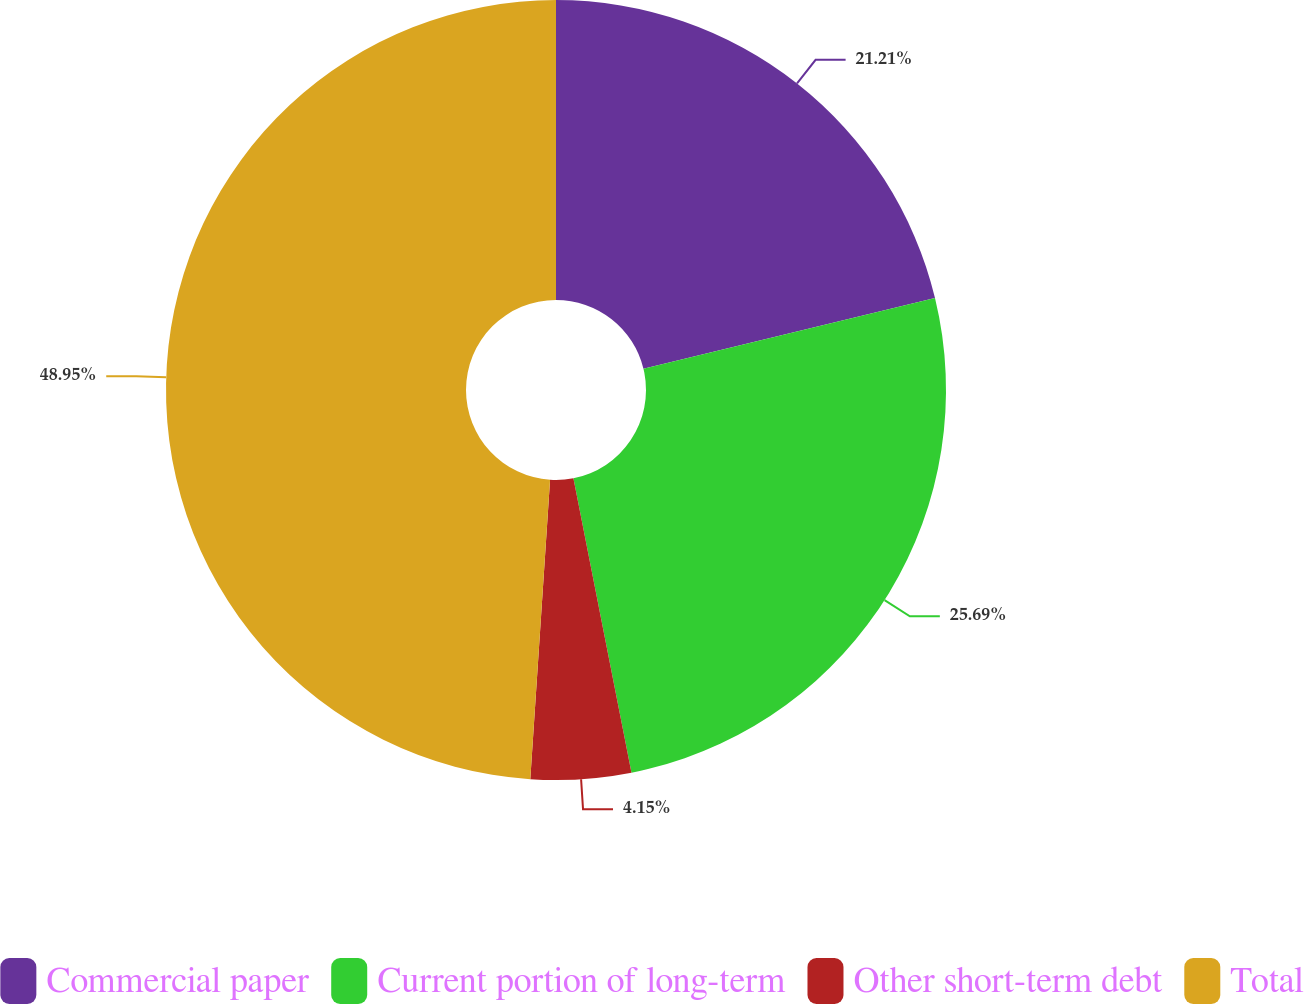Convert chart to OTSL. <chart><loc_0><loc_0><loc_500><loc_500><pie_chart><fcel>Commercial paper<fcel>Current portion of long-term<fcel>Other short-term debt<fcel>Total<nl><fcel>21.21%<fcel>25.69%<fcel>4.15%<fcel>48.95%<nl></chart> 